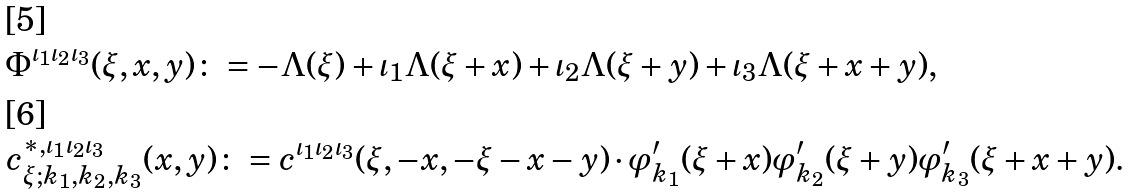Convert formula to latex. <formula><loc_0><loc_0><loc_500><loc_500>& \Phi ^ { \iota _ { 1 } \iota _ { 2 } \iota _ { 3 } } ( \xi , x , y ) \colon = - \Lambda ( \xi ) + \iota _ { 1 } \Lambda ( \xi + x ) + \iota _ { 2 } \Lambda ( \xi + y ) + \iota _ { 3 } \Lambda ( \xi + x + y ) , \\ & c ^ { \ast , \iota _ { 1 } \iota _ { 2 } \iota _ { 3 } } _ { \xi ; k _ { 1 } , k _ { 2 } , k _ { 3 } } ( x , y ) \colon = c ^ { \iota _ { 1 } \iota _ { 2 } \iota _ { 3 } } ( \xi , - x , - \xi - x - y ) \cdot \varphi ^ { \prime } _ { k _ { 1 } } ( \xi + x ) \varphi ^ { \prime } _ { k _ { 2 } } ( \xi + y ) \varphi ^ { \prime } _ { k _ { 3 } } ( \xi + x + y ) .</formula> 